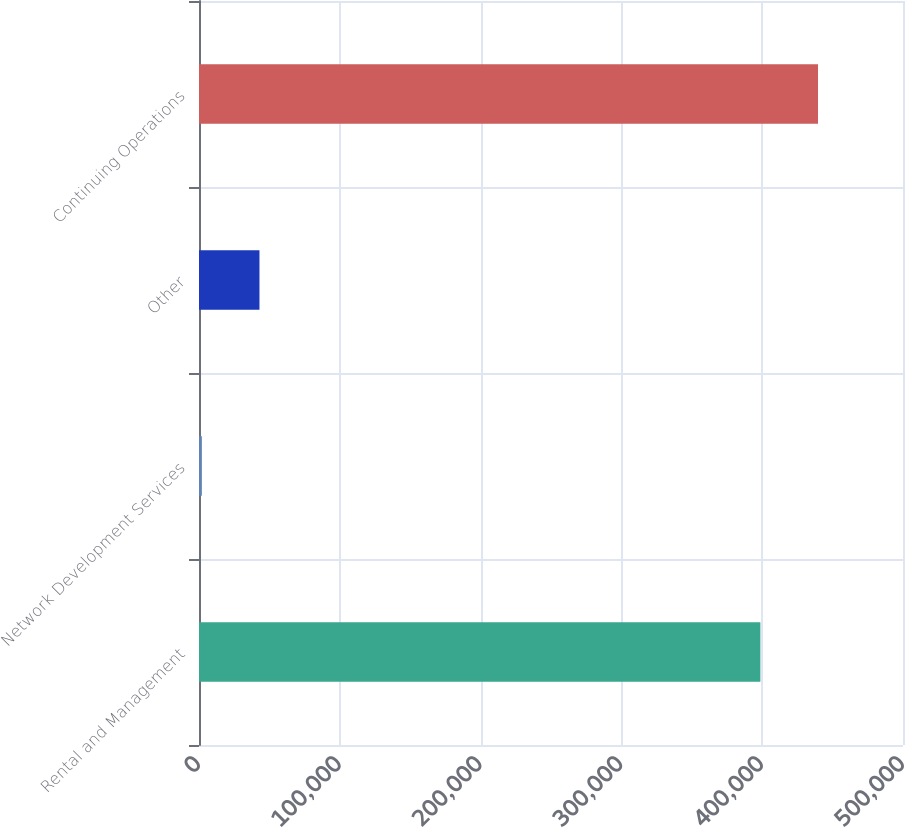Convert chart to OTSL. <chart><loc_0><loc_0><loc_500><loc_500><bar_chart><fcel>Rental and Management<fcel>Network Development Services<fcel>Other<fcel>Continuing Operations<nl><fcel>398715<fcel>2028<fcel>42950.6<fcel>439638<nl></chart> 